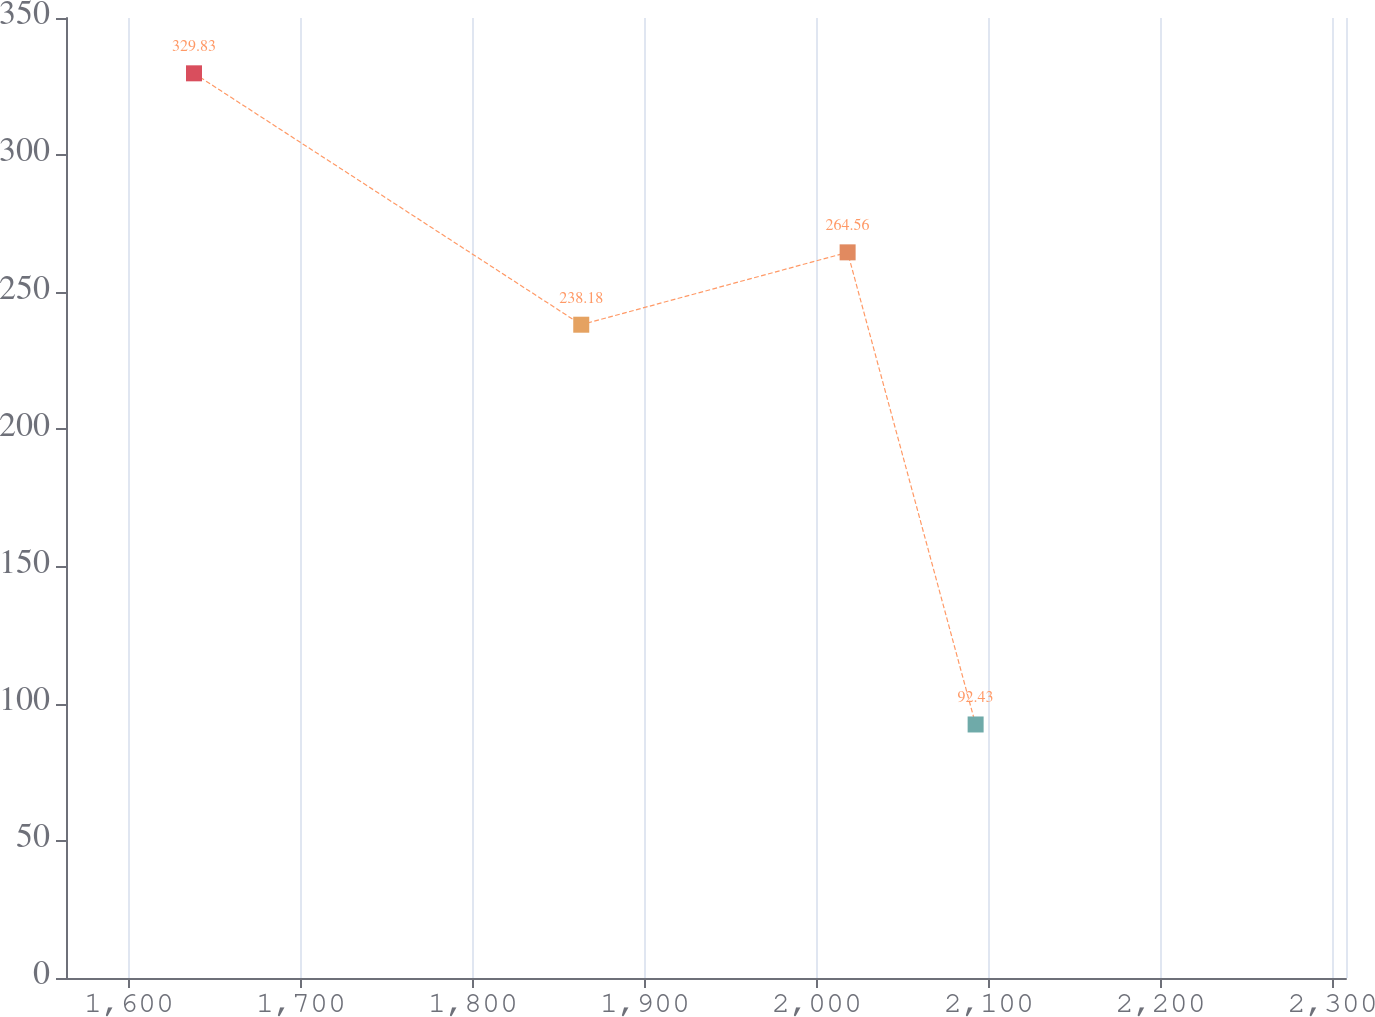<chart> <loc_0><loc_0><loc_500><loc_500><line_chart><ecel><fcel>(in millions)<nl><fcel>1637.78<fcel>329.83<nl><fcel>1862.96<fcel>238.18<nl><fcel>2017.85<fcel>264.56<nl><fcel>2092.28<fcel>92.43<nl><fcel>2382.08<fcel>66.05<nl></chart> 